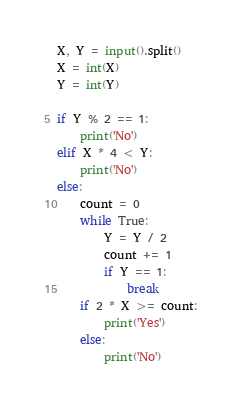Convert code to text. <code><loc_0><loc_0><loc_500><loc_500><_Python_>X, Y = input().split()
X = int(X)
Y = int(Y)

if Y % 2 == 1:
    print('No')
elif X * 4 < Y:
    print('No')
else:
    count = 0
    while True:
        Y = Y / 2
        count += 1
        if Y == 1:
            break
    if 2 * X >= count:
        print('Yes')
    else:
        print('No')
</code> 